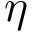Convert formula to latex. <formula><loc_0><loc_0><loc_500><loc_500>\eta</formula> 